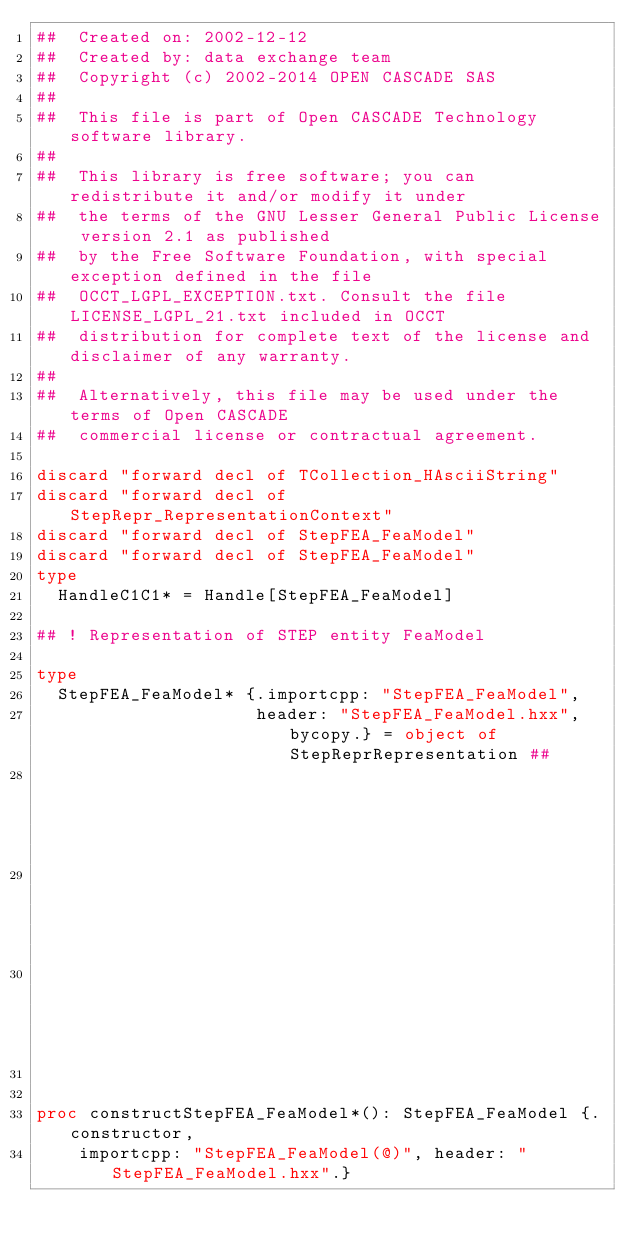<code> <loc_0><loc_0><loc_500><loc_500><_Nim_>##  Created on: 2002-12-12
##  Created by: data exchange team
##  Copyright (c) 2002-2014 OPEN CASCADE SAS
##
##  This file is part of Open CASCADE Technology software library.
##
##  This library is free software; you can redistribute it and/or modify it under
##  the terms of the GNU Lesser General Public License version 2.1 as published
##  by the Free Software Foundation, with special exception defined in the file
##  OCCT_LGPL_EXCEPTION.txt. Consult the file LICENSE_LGPL_21.txt included in OCCT
##  distribution for complete text of the license and disclaimer of any warranty.
##
##  Alternatively, this file may be used under the terms of Open CASCADE
##  commercial license or contractual agreement.

discard "forward decl of TCollection_HAsciiString"
discard "forward decl of StepRepr_RepresentationContext"
discard "forward decl of StepFEA_FeaModel"
discard "forward decl of StepFEA_FeaModel"
type
  HandleC1C1* = Handle[StepFEA_FeaModel]

## ! Representation of STEP entity FeaModel

type
  StepFEA_FeaModel* {.importcpp: "StepFEA_FeaModel",
                     header: "StepFEA_FeaModel.hxx", bycopy.} = object of StepReprRepresentation ##
                                                                                          ## !
                                                                                          ## Empty
                                                                                          ## constructor


proc constructStepFEA_FeaModel*(): StepFEA_FeaModel {.constructor,
    importcpp: "StepFEA_FeaModel(@)", header: "StepFEA_FeaModel.hxx".}</code> 